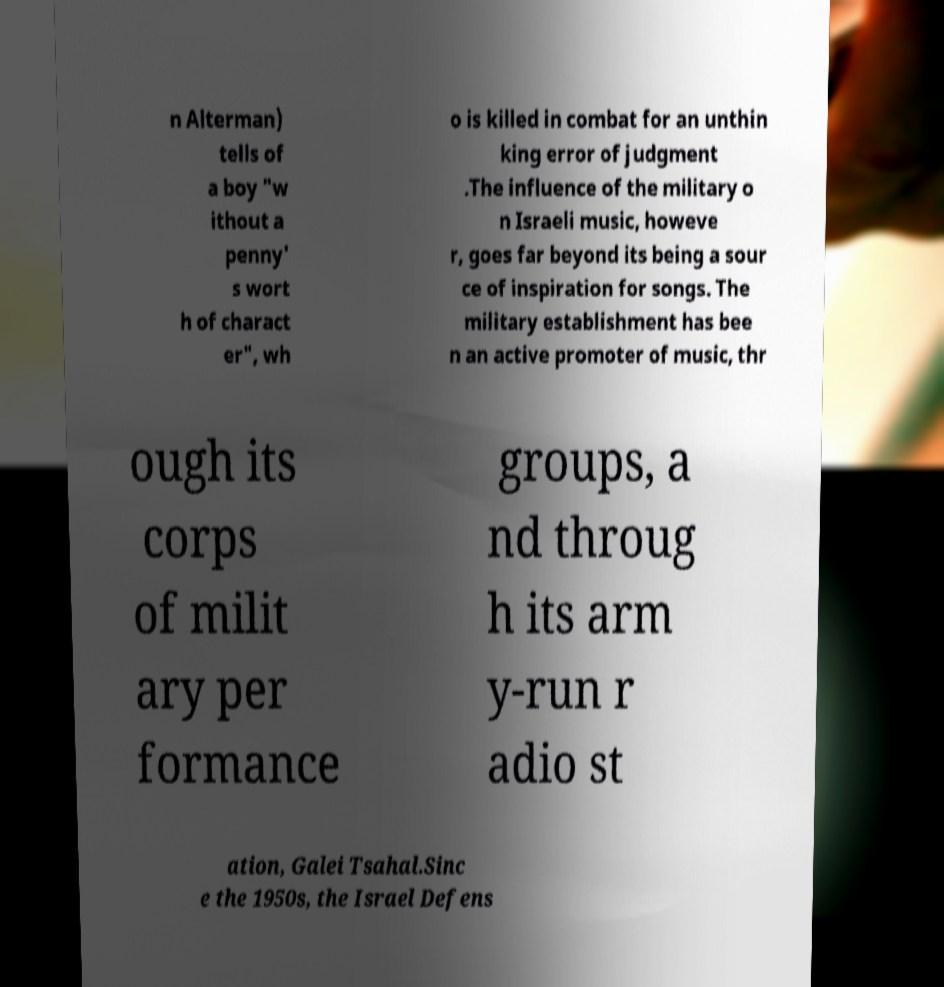Could you extract and type out the text from this image? n Alterman) tells of a boy "w ithout a penny' s wort h of charact er", wh o is killed in combat for an unthin king error of judgment .The influence of the military o n Israeli music, howeve r, goes far beyond its being a sour ce of inspiration for songs. The military establishment has bee n an active promoter of music, thr ough its corps of milit ary per formance groups, a nd throug h its arm y-run r adio st ation, Galei Tsahal.Sinc e the 1950s, the Israel Defens 